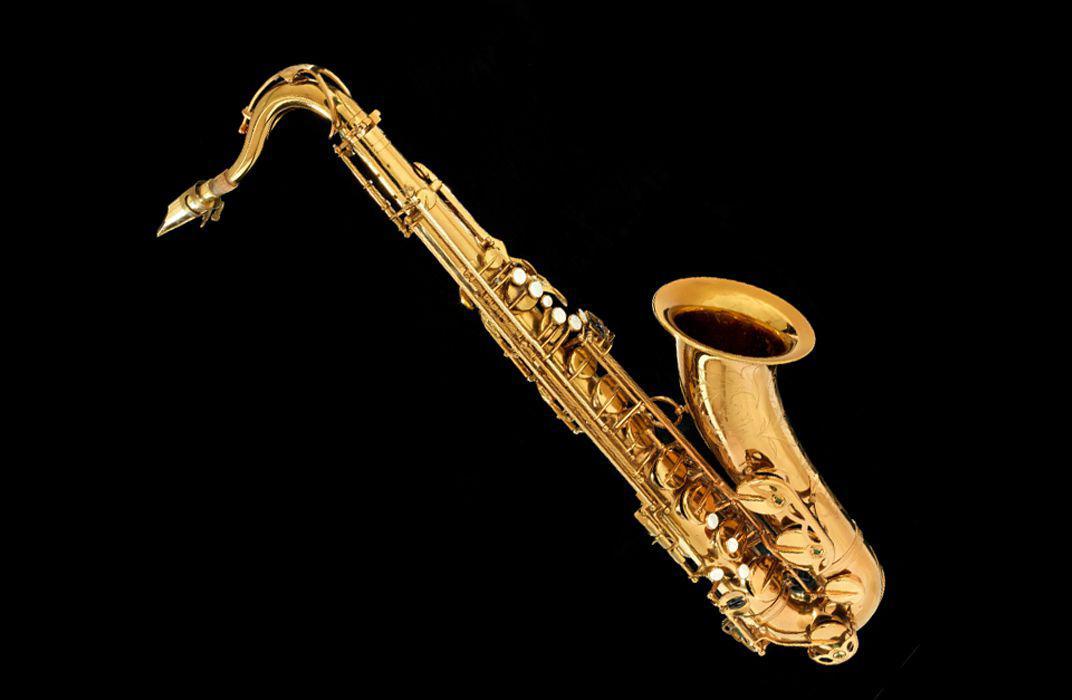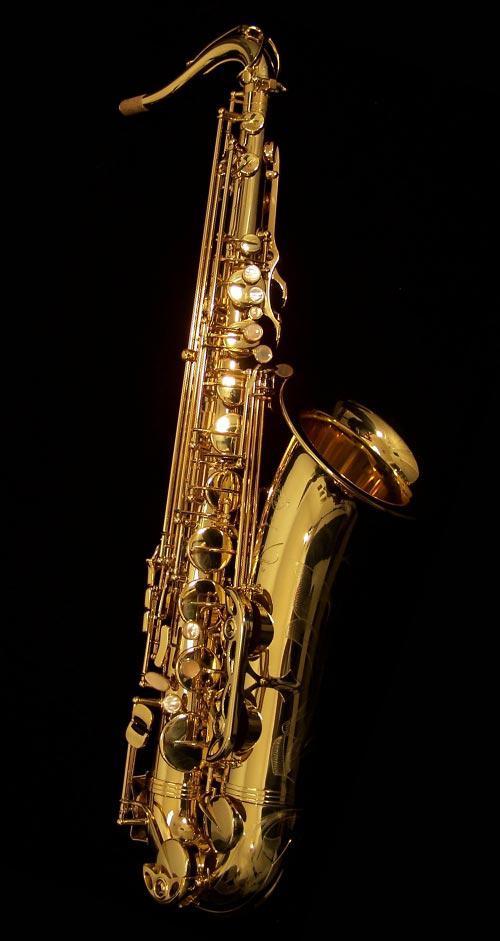The first image is the image on the left, the second image is the image on the right. Analyze the images presented: Is the assertion "All instruments on the left hand image are displayed vertically, while they are displayed horizontally or diagonally on the right hand images." valid? Answer yes or no. No. The first image is the image on the left, the second image is the image on the right. Examine the images to the left and right. Is the description "One image shows a single saxophone displayed nearly vertically, and one shows a saxophone displayed diagonally at about a 45-degree angle." accurate? Answer yes or no. Yes. 